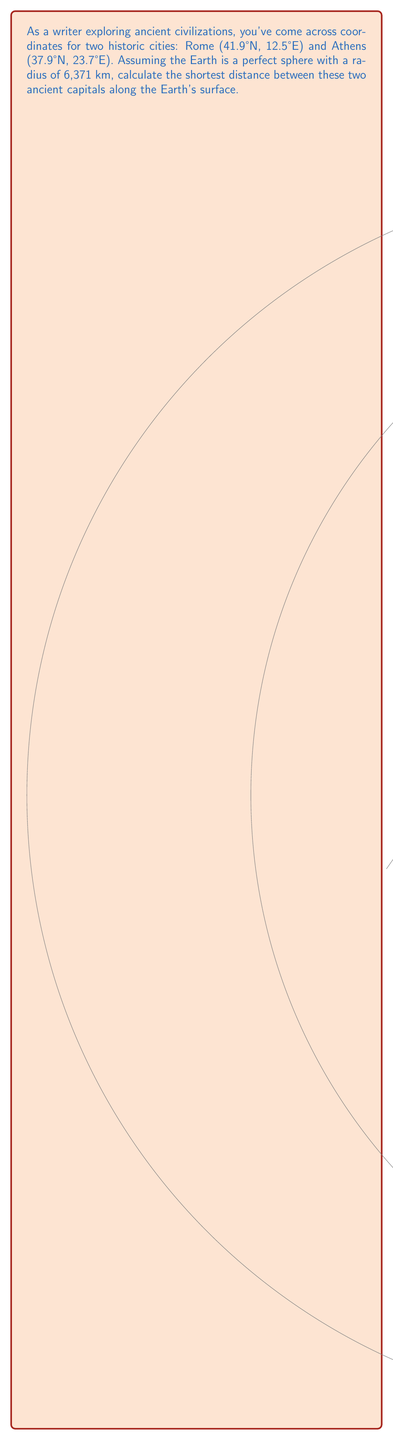Provide a solution to this math problem. To solve this problem, we'll use the Haversine formula, which calculates the great-circle distance between two points on a sphere given their longitudes and latitudes. Here's the step-by-step solution:

1) Convert the latitudes and longitudes from degrees to radians:
   Rome: $\phi_1 = 41.9° \times \frac{\pi}{180} = 0.7313$ rad, $\lambda_1 = 12.5° \times \frac{\pi}{180} = 0.2182$ rad
   Athens: $\phi_2 = 37.9° \times \frac{\pi}{180} = 0.6614$ rad, $\lambda_2 = 23.7° \times \frac{\pi}{180} = 0.4136$ rad

2) Calculate the difference in longitude:
   $\Delta\lambda = \lambda_2 - \lambda_1 = 0.4136 - 0.2182 = 0.1954$ rad

3) Apply the Haversine formula:
   $$a = \sin^2(\frac{\Delta\phi}{2}) + \cos(\phi_1) \cos(\phi_2) \sin^2(\frac{\Delta\lambda}{2})$$
   $$c = 2 \times \arctan2(\sqrt{a}, \sqrt{1-a})$$
   Where $\Delta\phi = \phi_2 - \phi_1 = 0.6614 - 0.7313 = -0.0699$ rad

4) Calculate $a$:
   $a = \sin^2(-0.0349) + \cos(0.7313) \cos(0.6614) \sin^2(0.0977) = 0.0147$

5) Calculate $c$:
   $c = 2 \times \arctan2(\sqrt{0.0147}, \sqrt{1-0.0147}) = 0.2425$ rad

6) Calculate the distance:
   $d = R \times c = 6371 \times 0.2425 = 1544.97$ km

Therefore, the shortest distance between Rome and Athens along the Earth's surface is approximately 1545 km.
Answer: 1545 km 